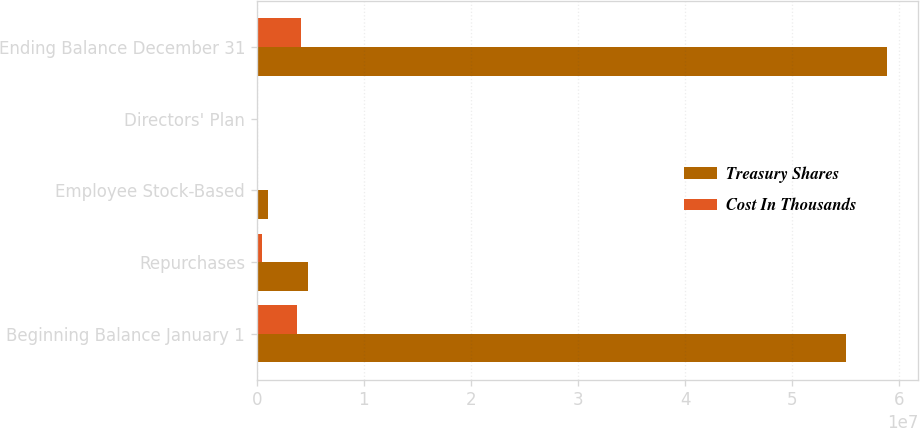<chart> <loc_0><loc_0><loc_500><loc_500><stacked_bar_chart><ecel><fcel>Beginning Balance January 1<fcel>Repurchases<fcel>Employee Stock-Based<fcel>Directors' Plan<fcel>Ending Balance December 31<nl><fcel>Treasury Shares<fcel>5.50538e+07<fcel>4.7923e+06<fcel>1.02541e+06<fcel>5220<fcel>5.88155e+07<nl><fcel>Cost In Thousands<fcel>3.73486e+06<fcel>512351<fcel>71636<fcel>366<fcel>4.17521e+06<nl></chart> 